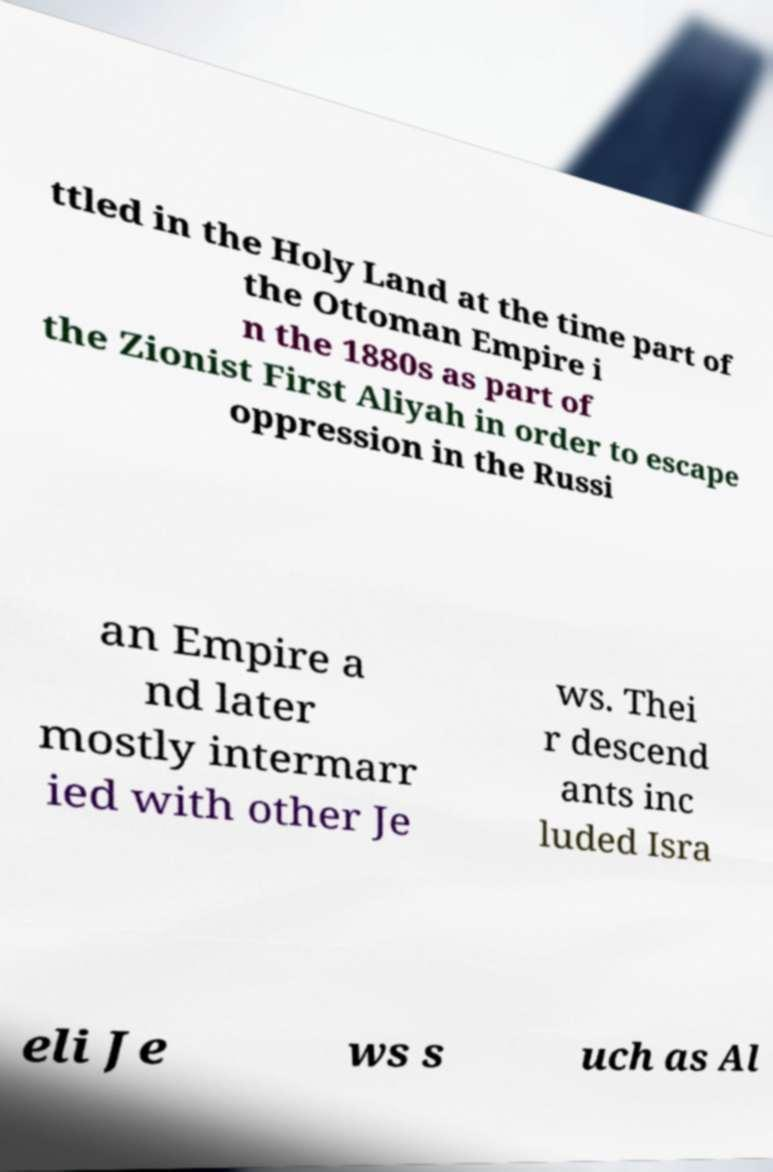What messages or text are displayed in this image? I need them in a readable, typed format. ttled in the Holy Land at the time part of the Ottoman Empire i n the 1880s as part of the Zionist First Aliyah in order to escape oppression in the Russi an Empire a nd later mostly intermarr ied with other Je ws. Thei r descend ants inc luded Isra eli Je ws s uch as Al 